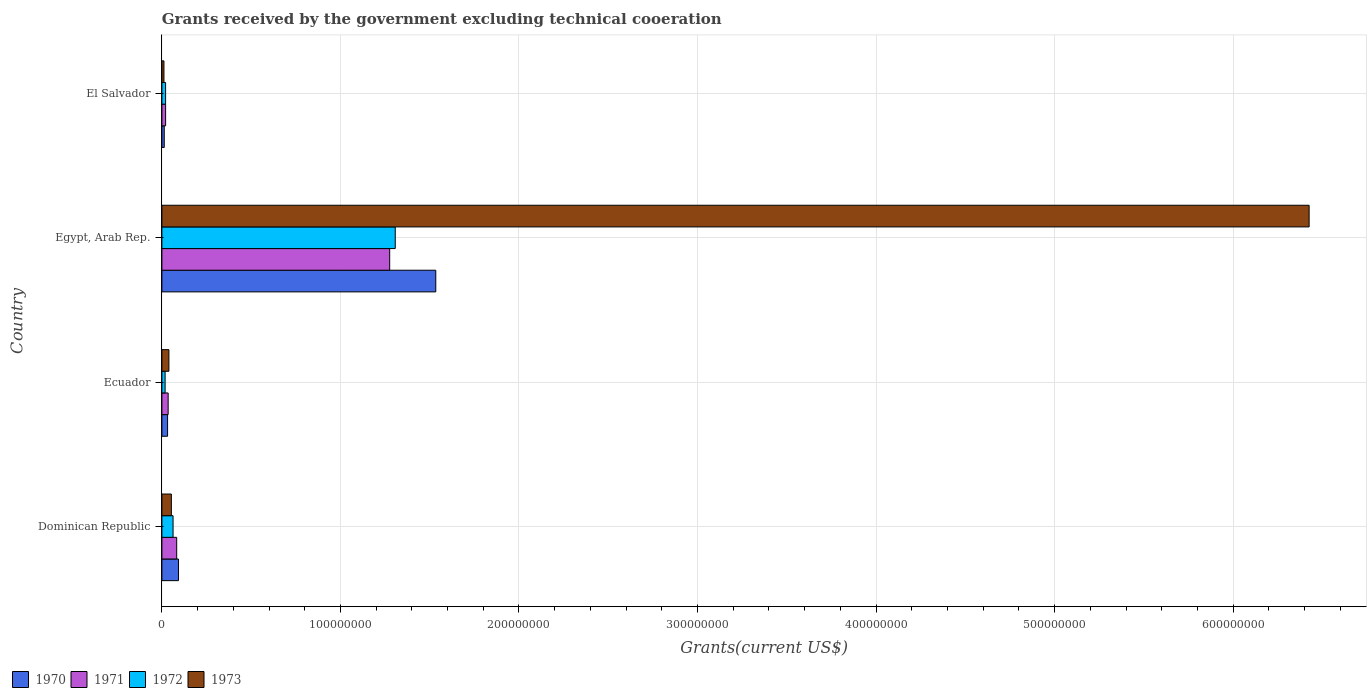Are the number of bars per tick equal to the number of legend labels?
Your response must be concise. Yes. Are the number of bars on each tick of the Y-axis equal?
Provide a short and direct response. Yes. How many bars are there on the 2nd tick from the top?
Your response must be concise. 4. What is the label of the 1st group of bars from the top?
Provide a succinct answer. El Salvador. In how many cases, is the number of bars for a given country not equal to the number of legend labels?
Keep it short and to the point. 0. What is the total grants received by the government in 1972 in Dominican Republic?
Offer a terse response. 6.25e+06. Across all countries, what is the maximum total grants received by the government in 1971?
Ensure brevity in your answer.  1.28e+08. Across all countries, what is the minimum total grants received by the government in 1973?
Your answer should be very brief. 1.15e+06. In which country was the total grants received by the government in 1972 maximum?
Keep it short and to the point. Egypt, Arab Rep. In which country was the total grants received by the government in 1972 minimum?
Provide a short and direct response. Ecuador. What is the total total grants received by the government in 1972 in the graph?
Keep it short and to the point. 1.41e+08. What is the difference between the total grants received by the government in 1971 in Ecuador and that in El Salvador?
Keep it short and to the point. 1.42e+06. What is the difference between the total grants received by the government in 1973 in Dominican Republic and the total grants received by the government in 1971 in Ecuador?
Your answer should be compact. 1.80e+06. What is the average total grants received by the government in 1970 per country?
Offer a terse response. 4.18e+07. What is the difference between the total grants received by the government in 1973 and total grants received by the government in 1972 in El Salvador?
Ensure brevity in your answer.  -9.20e+05. What is the ratio of the total grants received by the government in 1970 in Dominican Republic to that in Ecuador?
Provide a short and direct response. 2.92. Is the total grants received by the government in 1973 in Egypt, Arab Rep. less than that in El Salvador?
Provide a short and direct response. No. Is the difference between the total grants received by the government in 1973 in Dominican Republic and Egypt, Arab Rep. greater than the difference between the total grants received by the government in 1972 in Dominican Republic and Egypt, Arab Rep.?
Provide a short and direct response. No. What is the difference between the highest and the second highest total grants received by the government in 1970?
Your response must be concise. 1.44e+08. What is the difference between the highest and the lowest total grants received by the government in 1970?
Your answer should be very brief. 1.52e+08. Is it the case that in every country, the sum of the total grants received by the government in 1970 and total grants received by the government in 1971 is greater than the total grants received by the government in 1972?
Give a very brief answer. Yes. What is the difference between two consecutive major ticks on the X-axis?
Your response must be concise. 1.00e+08. Are the values on the major ticks of X-axis written in scientific E-notation?
Provide a short and direct response. No. Does the graph contain any zero values?
Ensure brevity in your answer.  No. Does the graph contain grids?
Give a very brief answer. Yes. How are the legend labels stacked?
Your answer should be very brief. Horizontal. What is the title of the graph?
Offer a terse response. Grants received by the government excluding technical cooeration. Does "2002" appear as one of the legend labels in the graph?
Provide a succinct answer. No. What is the label or title of the X-axis?
Your response must be concise. Grants(current US$). What is the Grants(current US$) of 1970 in Dominican Republic?
Make the answer very short. 9.28e+06. What is the Grants(current US$) in 1971 in Dominican Republic?
Your answer should be very brief. 8.28e+06. What is the Grants(current US$) in 1972 in Dominican Republic?
Your answer should be compact. 6.25e+06. What is the Grants(current US$) in 1973 in Dominican Republic?
Your answer should be compact. 5.30e+06. What is the Grants(current US$) of 1970 in Ecuador?
Your answer should be very brief. 3.18e+06. What is the Grants(current US$) in 1971 in Ecuador?
Make the answer very short. 3.50e+06. What is the Grants(current US$) of 1972 in Ecuador?
Offer a very short reply. 1.80e+06. What is the Grants(current US$) of 1973 in Ecuador?
Keep it short and to the point. 3.92e+06. What is the Grants(current US$) in 1970 in Egypt, Arab Rep.?
Offer a terse response. 1.53e+08. What is the Grants(current US$) in 1971 in Egypt, Arab Rep.?
Your response must be concise. 1.28e+08. What is the Grants(current US$) in 1972 in Egypt, Arab Rep.?
Make the answer very short. 1.31e+08. What is the Grants(current US$) of 1973 in Egypt, Arab Rep.?
Provide a succinct answer. 6.43e+08. What is the Grants(current US$) in 1970 in El Salvador?
Provide a succinct answer. 1.32e+06. What is the Grants(current US$) in 1971 in El Salvador?
Your answer should be compact. 2.08e+06. What is the Grants(current US$) in 1972 in El Salvador?
Offer a very short reply. 2.07e+06. What is the Grants(current US$) in 1973 in El Salvador?
Offer a very short reply. 1.15e+06. Across all countries, what is the maximum Grants(current US$) of 1970?
Keep it short and to the point. 1.53e+08. Across all countries, what is the maximum Grants(current US$) in 1971?
Ensure brevity in your answer.  1.28e+08. Across all countries, what is the maximum Grants(current US$) in 1972?
Your response must be concise. 1.31e+08. Across all countries, what is the maximum Grants(current US$) in 1973?
Your response must be concise. 6.43e+08. Across all countries, what is the minimum Grants(current US$) in 1970?
Ensure brevity in your answer.  1.32e+06. Across all countries, what is the minimum Grants(current US$) in 1971?
Offer a terse response. 2.08e+06. Across all countries, what is the minimum Grants(current US$) in 1972?
Your response must be concise. 1.80e+06. Across all countries, what is the minimum Grants(current US$) in 1973?
Offer a very short reply. 1.15e+06. What is the total Grants(current US$) in 1970 in the graph?
Your answer should be compact. 1.67e+08. What is the total Grants(current US$) in 1971 in the graph?
Ensure brevity in your answer.  1.41e+08. What is the total Grants(current US$) in 1972 in the graph?
Offer a terse response. 1.41e+08. What is the total Grants(current US$) in 1973 in the graph?
Provide a short and direct response. 6.53e+08. What is the difference between the Grants(current US$) of 1970 in Dominican Republic and that in Ecuador?
Provide a short and direct response. 6.10e+06. What is the difference between the Grants(current US$) of 1971 in Dominican Republic and that in Ecuador?
Ensure brevity in your answer.  4.78e+06. What is the difference between the Grants(current US$) of 1972 in Dominican Republic and that in Ecuador?
Offer a very short reply. 4.45e+06. What is the difference between the Grants(current US$) in 1973 in Dominican Republic and that in Ecuador?
Make the answer very short. 1.38e+06. What is the difference between the Grants(current US$) in 1970 in Dominican Republic and that in Egypt, Arab Rep.?
Provide a succinct answer. -1.44e+08. What is the difference between the Grants(current US$) in 1971 in Dominican Republic and that in Egypt, Arab Rep.?
Keep it short and to the point. -1.19e+08. What is the difference between the Grants(current US$) in 1972 in Dominican Republic and that in Egypt, Arab Rep.?
Your answer should be compact. -1.24e+08. What is the difference between the Grants(current US$) of 1973 in Dominican Republic and that in Egypt, Arab Rep.?
Your answer should be very brief. -6.37e+08. What is the difference between the Grants(current US$) of 1970 in Dominican Republic and that in El Salvador?
Your answer should be very brief. 7.96e+06. What is the difference between the Grants(current US$) in 1971 in Dominican Republic and that in El Salvador?
Your answer should be very brief. 6.20e+06. What is the difference between the Grants(current US$) in 1972 in Dominican Republic and that in El Salvador?
Give a very brief answer. 4.18e+06. What is the difference between the Grants(current US$) in 1973 in Dominican Republic and that in El Salvador?
Ensure brevity in your answer.  4.15e+06. What is the difference between the Grants(current US$) in 1970 in Ecuador and that in Egypt, Arab Rep.?
Make the answer very short. -1.50e+08. What is the difference between the Grants(current US$) in 1971 in Ecuador and that in Egypt, Arab Rep.?
Give a very brief answer. -1.24e+08. What is the difference between the Grants(current US$) of 1972 in Ecuador and that in Egypt, Arab Rep.?
Offer a very short reply. -1.29e+08. What is the difference between the Grants(current US$) in 1973 in Ecuador and that in Egypt, Arab Rep.?
Keep it short and to the point. -6.39e+08. What is the difference between the Grants(current US$) of 1970 in Ecuador and that in El Salvador?
Provide a succinct answer. 1.86e+06. What is the difference between the Grants(current US$) of 1971 in Ecuador and that in El Salvador?
Offer a terse response. 1.42e+06. What is the difference between the Grants(current US$) in 1973 in Ecuador and that in El Salvador?
Provide a succinct answer. 2.77e+06. What is the difference between the Grants(current US$) in 1970 in Egypt, Arab Rep. and that in El Salvador?
Your answer should be compact. 1.52e+08. What is the difference between the Grants(current US$) of 1971 in Egypt, Arab Rep. and that in El Salvador?
Offer a terse response. 1.26e+08. What is the difference between the Grants(current US$) in 1972 in Egypt, Arab Rep. and that in El Salvador?
Offer a terse response. 1.29e+08. What is the difference between the Grants(current US$) in 1973 in Egypt, Arab Rep. and that in El Salvador?
Provide a short and direct response. 6.41e+08. What is the difference between the Grants(current US$) in 1970 in Dominican Republic and the Grants(current US$) in 1971 in Ecuador?
Your answer should be very brief. 5.78e+06. What is the difference between the Grants(current US$) of 1970 in Dominican Republic and the Grants(current US$) of 1972 in Ecuador?
Keep it short and to the point. 7.48e+06. What is the difference between the Grants(current US$) in 1970 in Dominican Republic and the Grants(current US$) in 1973 in Ecuador?
Provide a succinct answer. 5.36e+06. What is the difference between the Grants(current US$) in 1971 in Dominican Republic and the Grants(current US$) in 1972 in Ecuador?
Offer a very short reply. 6.48e+06. What is the difference between the Grants(current US$) of 1971 in Dominican Republic and the Grants(current US$) of 1973 in Ecuador?
Your answer should be compact. 4.36e+06. What is the difference between the Grants(current US$) in 1972 in Dominican Republic and the Grants(current US$) in 1973 in Ecuador?
Offer a very short reply. 2.33e+06. What is the difference between the Grants(current US$) in 1970 in Dominican Republic and the Grants(current US$) in 1971 in Egypt, Arab Rep.?
Provide a succinct answer. -1.18e+08. What is the difference between the Grants(current US$) in 1970 in Dominican Republic and the Grants(current US$) in 1972 in Egypt, Arab Rep.?
Ensure brevity in your answer.  -1.21e+08. What is the difference between the Grants(current US$) in 1970 in Dominican Republic and the Grants(current US$) in 1973 in Egypt, Arab Rep.?
Keep it short and to the point. -6.33e+08. What is the difference between the Grants(current US$) in 1971 in Dominican Republic and the Grants(current US$) in 1972 in Egypt, Arab Rep.?
Make the answer very short. -1.22e+08. What is the difference between the Grants(current US$) of 1971 in Dominican Republic and the Grants(current US$) of 1973 in Egypt, Arab Rep.?
Your answer should be compact. -6.34e+08. What is the difference between the Grants(current US$) in 1972 in Dominican Republic and the Grants(current US$) in 1973 in Egypt, Arab Rep.?
Keep it short and to the point. -6.36e+08. What is the difference between the Grants(current US$) in 1970 in Dominican Republic and the Grants(current US$) in 1971 in El Salvador?
Your answer should be very brief. 7.20e+06. What is the difference between the Grants(current US$) of 1970 in Dominican Republic and the Grants(current US$) of 1972 in El Salvador?
Offer a very short reply. 7.21e+06. What is the difference between the Grants(current US$) of 1970 in Dominican Republic and the Grants(current US$) of 1973 in El Salvador?
Keep it short and to the point. 8.13e+06. What is the difference between the Grants(current US$) of 1971 in Dominican Republic and the Grants(current US$) of 1972 in El Salvador?
Provide a succinct answer. 6.21e+06. What is the difference between the Grants(current US$) in 1971 in Dominican Republic and the Grants(current US$) in 1973 in El Salvador?
Make the answer very short. 7.13e+06. What is the difference between the Grants(current US$) of 1972 in Dominican Republic and the Grants(current US$) of 1973 in El Salvador?
Provide a short and direct response. 5.10e+06. What is the difference between the Grants(current US$) of 1970 in Ecuador and the Grants(current US$) of 1971 in Egypt, Arab Rep.?
Keep it short and to the point. -1.24e+08. What is the difference between the Grants(current US$) of 1970 in Ecuador and the Grants(current US$) of 1972 in Egypt, Arab Rep.?
Provide a succinct answer. -1.28e+08. What is the difference between the Grants(current US$) in 1970 in Ecuador and the Grants(current US$) in 1973 in Egypt, Arab Rep.?
Provide a succinct answer. -6.39e+08. What is the difference between the Grants(current US$) in 1971 in Ecuador and the Grants(current US$) in 1972 in Egypt, Arab Rep.?
Your answer should be compact. -1.27e+08. What is the difference between the Grants(current US$) in 1971 in Ecuador and the Grants(current US$) in 1973 in Egypt, Arab Rep.?
Ensure brevity in your answer.  -6.39e+08. What is the difference between the Grants(current US$) in 1972 in Ecuador and the Grants(current US$) in 1973 in Egypt, Arab Rep.?
Your answer should be compact. -6.41e+08. What is the difference between the Grants(current US$) in 1970 in Ecuador and the Grants(current US$) in 1971 in El Salvador?
Offer a very short reply. 1.10e+06. What is the difference between the Grants(current US$) of 1970 in Ecuador and the Grants(current US$) of 1972 in El Salvador?
Provide a succinct answer. 1.11e+06. What is the difference between the Grants(current US$) in 1970 in Ecuador and the Grants(current US$) in 1973 in El Salvador?
Ensure brevity in your answer.  2.03e+06. What is the difference between the Grants(current US$) of 1971 in Ecuador and the Grants(current US$) of 1972 in El Salvador?
Give a very brief answer. 1.43e+06. What is the difference between the Grants(current US$) of 1971 in Ecuador and the Grants(current US$) of 1973 in El Salvador?
Offer a terse response. 2.35e+06. What is the difference between the Grants(current US$) in 1972 in Ecuador and the Grants(current US$) in 1973 in El Salvador?
Offer a very short reply. 6.50e+05. What is the difference between the Grants(current US$) of 1970 in Egypt, Arab Rep. and the Grants(current US$) of 1971 in El Salvador?
Keep it short and to the point. 1.51e+08. What is the difference between the Grants(current US$) of 1970 in Egypt, Arab Rep. and the Grants(current US$) of 1972 in El Salvador?
Give a very brief answer. 1.51e+08. What is the difference between the Grants(current US$) of 1970 in Egypt, Arab Rep. and the Grants(current US$) of 1973 in El Salvador?
Give a very brief answer. 1.52e+08. What is the difference between the Grants(current US$) in 1971 in Egypt, Arab Rep. and the Grants(current US$) in 1972 in El Salvador?
Provide a short and direct response. 1.26e+08. What is the difference between the Grants(current US$) of 1971 in Egypt, Arab Rep. and the Grants(current US$) of 1973 in El Salvador?
Provide a short and direct response. 1.26e+08. What is the difference between the Grants(current US$) of 1972 in Egypt, Arab Rep. and the Grants(current US$) of 1973 in El Salvador?
Provide a succinct answer. 1.30e+08. What is the average Grants(current US$) of 1970 per country?
Give a very brief answer. 4.18e+07. What is the average Grants(current US$) in 1971 per country?
Your answer should be compact. 3.54e+07. What is the average Grants(current US$) in 1972 per country?
Keep it short and to the point. 3.52e+07. What is the average Grants(current US$) of 1973 per country?
Make the answer very short. 1.63e+08. What is the difference between the Grants(current US$) of 1970 and Grants(current US$) of 1972 in Dominican Republic?
Ensure brevity in your answer.  3.03e+06. What is the difference between the Grants(current US$) of 1970 and Grants(current US$) of 1973 in Dominican Republic?
Your response must be concise. 3.98e+06. What is the difference between the Grants(current US$) of 1971 and Grants(current US$) of 1972 in Dominican Republic?
Give a very brief answer. 2.03e+06. What is the difference between the Grants(current US$) of 1971 and Grants(current US$) of 1973 in Dominican Republic?
Your answer should be very brief. 2.98e+06. What is the difference between the Grants(current US$) in 1972 and Grants(current US$) in 1973 in Dominican Republic?
Give a very brief answer. 9.50e+05. What is the difference between the Grants(current US$) in 1970 and Grants(current US$) in 1971 in Ecuador?
Provide a succinct answer. -3.20e+05. What is the difference between the Grants(current US$) of 1970 and Grants(current US$) of 1972 in Ecuador?
Offer a terse response. 1.38e+06. What is the difference between the Grants(current US$) in 1970 and Grants(current US$) in 1973 in Ecuador?
Make the answer very short. -7.40e+05. What is the difference between the Grants(current US$) in 1971 and Grants(current US$) in 1972 in Ecuador?
Provide a short and direct response. 1.70e+06. What is the difference between the Grants(current US$) in 1971 and Grants(current US$) in 1973 in Ecuador?
Offer a very short reply. -4.20e+05. What is the difference between the Grants(current US$) in 1972 and Grants(current US$) in 1973 in Ecuador?
Give a very brief answer. -2.12e+06. What is the difference between the Grants(current US$) of 1970 and Grants(current US$) of 1971 in Egypt, Arab Rep.?
Ensure brevity in your answer.  2.58e+07. What is the difference between the Grants(current US$) in 1970 and Grants(current US$) in 1972 in Egypt, Arab Rep.?
Your answer should be compact. 2.27e+07. What is the difference between the Grants(current US$) in 1970 and Grants(current US$) in 1973 in Egypt, Arab Rep.?
Offer a terse response. -4.89e+08. What is the difference between the Grants(current US$) in 1971 and Grants(current US$) in 1972 in Egypt, Arab Rep.?
Give a very brief answer. -3.12e+06. What is the difference between the Grants(current US$) of 1971 and Grants(current US$) of 1973 in Egypt, Arab Rep.?
Your response must be concise. -5.15e+08. What is the difference between the Grants(current US$) of 1972 and Grants(current US$) of 1973 in Egypt, Arab Rep.?
Give a very brief answer. -5.12e+08. What is the difference between the Grants(current US$) of 1970 and Grants(current US$) of 1971 in El Salvador?
Provide a short and direct response. -7.60e+05. What is the difference between the Grants(current US$) of 1970 and Grants(current US$) of 1972 in El Salvador?
Your response must be concise. -7.50e+05. What is the difference between the Grants(current US$) in 1970 and Grants(current US$) in 1973 in El Salvador?
Make the answer very short. 1.70e+05. What is the difference between the Grants(current US$) of 1971 and Grants(current US$) of 1972 in El Salvador?
Ensure brevity in your answer.  10000. What is the difference between the Grants(current US$) of 1971 and Grants(current US$) of 1973 in El Salvador?
Your answer should be very brief. 9.30e+05. What is the difference between the Grants(current US$) of 1972 and Grants(current US$) of 1973 in El Salvador?
Offer a very short reply. 9.20e+05. What is the ratio of the Grants(current US$) of 1970 in Dominican Republic to that in Ecuador?
Your response must be concise. 2.92. What is the ratio of the Grants(current US$) in 1971 in Dominican Republic to that in Ecuador?
Offer a terse response. 2.37. What is the ratio of the Grants(current US$) in 1972 in Dominican Republic to that in Ecuador?
Your response must be concise. 3.47. What is the ratio of the Grants(current US$) in 1973 in Dominican Republic to that in Ecuador?
Provide a succinct answer. 1.35. What is the ratio of the Grants(current US$) in 1970 in Dominican Republic to that in Egypt, Arab Rep.?
Your response must be concise. 0.06. What is the ratio of the Grants(current US$) of 1971 in Dominican Republic to that in Egypt, Arab Rep.?
Offer a very short reply. 0.06. What is the ratio of the Grants(current US$) in 1972 in Dominican Republic to that in Egypt, Arab Rep.?
Keep it short and to the point. 0.05. What is the ratio of the Grants(current US$) in 1973 in Dominican Republic to that in Egypt, Arab Rep.?
Offer a terse response. 0.01. What is the ratio of the Grants(current US$) of 1970 in Dominican Republic to that in El Salvador?
Offer a terse response. 7.03. What is the ratio of the Grants(current US$) of 1971 in Dominican Republic to that in El Salvador?
Offer a very short reply. 3.98. What is the ratio of the Grants(current US$) of 1972 in Dominican Republic to that in El Salvador?
Offer a terse response. 3.02. What is the ratio of the Grants(current US$) of 1973 in Dominican Republic to that in El Salvador?
Provide a short and direct response. 4.61. What is the ratio of the Grants(current US$) in 1970 in Ecuador to that in Egypt, Arab Rep.?
Your answer should be compact. 0.02. What is the ratio of the Grants(current US$) of 1971 in Ecuador to that in Egypt, Arab Rep.?
Provide a succinct answer. 0.03. What is the ratio of the Grants(current US$) of 1972 in Ecuador to that in Egypt, Arab Rep.?
Your answer should be very brief. 0.01. What is the ratio of the Grants(current US$) of 1973 in Ecuador to that in Egypt, Arab Rep.?
Offer a very short reply. 0.01. What is the ratio of the Grants(current US$) of 1970 in Ecuador to that in El Salvador?
Keep it short and to the point. 2.41. What is the ratio of the Grants(current US$) in 1971 in Ecuador to that in El Salvador?
Your answer should be very brief. 1.68. What is the ratio of the Grants(current US$) in 1972 in Ecuador to that in El Salvador?
Ensure brevity in your answer.  0.87. What is the ratio of the Grants(current US$) in 1973 in Ecuador to that in El Salvador?
Offer a terse response. 3.41. What is the ratio of the Grants(current US$) in 1970 in Egypt, Arab Rep. to that in El Salvador?
Make the answer very short. 116.21. What is the ratio of the Grants(current US$) of 1971 in Egypt, Arab Rep. to that in El Salvador?
Ensure brevity in your answer.  61.34. What is the ratio of the Grants(current US$) of 1972 in Egypt, Arab Rep. to that in El Salvador?
Provide a short and direct response. 63.14. What is the ratio of the Grants(current US$) of 1973 in Egypt, Arab Rep. to that in El Salvador?
Provide a short and direct response. 558.74. What is the difference between the highest and the second highest Grants(current US$) in 1970?
Provide a short and direct response. 1.44e+08. What is the difference between the highest and the second highest Grants(current US$) in 1971?
Provide a short and direct response. 1.19e+08. What is the difference between the highest and the second highest Grants(current US$) in 1972?
Offer a terse response. 1.24e+08. What is the difference between the highest and the second highest Grants(current US$) of 1973?
Offer a terse response. 6.37e+08. What is the difference between the highest and the lowest Grants(current US$) of 1970?
Your answer should be very brief. 1.52e+08. What is the difference between the highest and the lowest Grants(current US$) in 1971?
Your answer should be compact. 1.26e+08. What is the difference between the highest and the lowest Grants(current US$) in 1972?
Offer a terse response. 1.29e+08. What is the difference between the highest and the lowest Grants(current US$) in 1973?
Ensure brevity in your answer.  6.41e+08. 